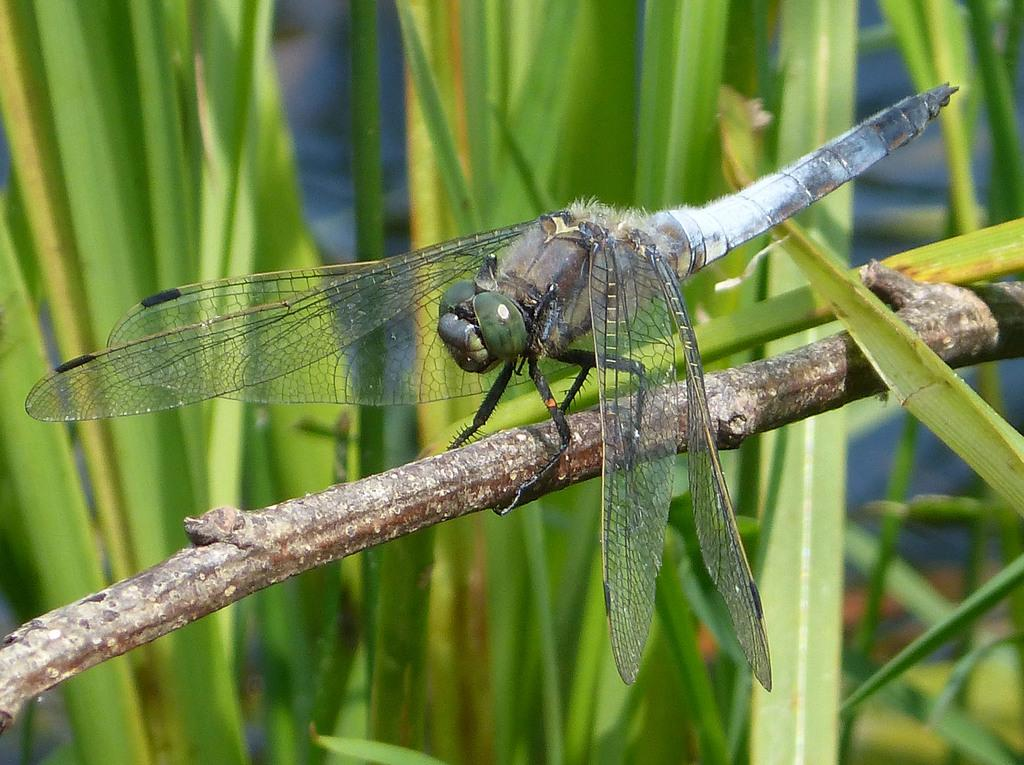What is there is a fly on what object in the image? There is a fly on a stick in the image. What other elements can be seen in the image besides the fly and the stick? There are plants in the image. What type of sidewalk can be seen in the image? There is no sidewalk present in the image. How many ladybugs are visible on the plants in the image? There are no ladybugs visible on the plants in the image. 